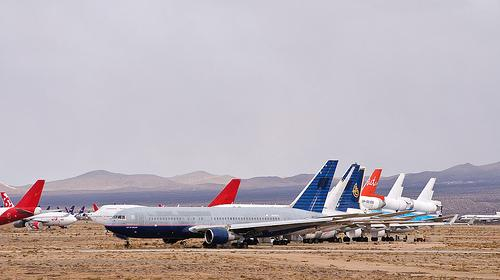Describe the colors of the tails and engines of the planes in the image. The planes have tails in red, white, and blue, with blue engines under their wings. Highlight the prominent characteristics of the airplanes and the environment in which they are stationed. The image features a diverse fleet of parked airplanes with different tail colors and markings against a desert environment with hazy mountains and a gray sky. What are the key elements observed in the image involving the planes and the landscape? Key elements include colorful airplane tails, blue engines, windows, wheels, a desert landscape, mountains, and a gray sky. Mention the main attributes of the airplanes in the image. The airplanes have various tail colors like red, white, and blue, with blue engines and windows along their body, all parked in a desert setting. Provide a brief overview of the general environment present in the image. The image features airplanes with colorful tails parked in a desert, with mountains in the background and a gray sky overhead. Short description of the natural background elements of the photograph. In the background, there are hazy mountains on the horizon, and a pale blue sky with a flat, rough brown ground beneath the planes. Briefly mention the landscape where the planes are parked and the sky above them. The planes are parked on flat, rough brown ground with a solid gray sky above them. What are the unique features of the planes visible in the image? The planes in the image have distinct colorful tails, a blue engine, a row of windows, and landing gear with black wheels. Describe the state and position of the airplanes in the image. Multiple airplanes are parked on a desert terrain, overlapping each other, with some having visible wheels and rows of windows. In one sentence, describe the setting in which the planes are parked. The planes are parked in a desert location, with rolling hills in the distance and a clear sky above. 